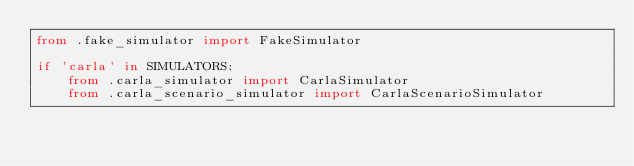Convert code to text. <code><loc_0><loc_0><loc_500><loc_500><_Python_>from .fake_simulator import FakeSimulator

if 'carla' in SIMULATORS:
    from .carla_simulator import CarlaSimulator
    from .carla_scenario_simulator import CarlaScenarioSimulator
</code> 